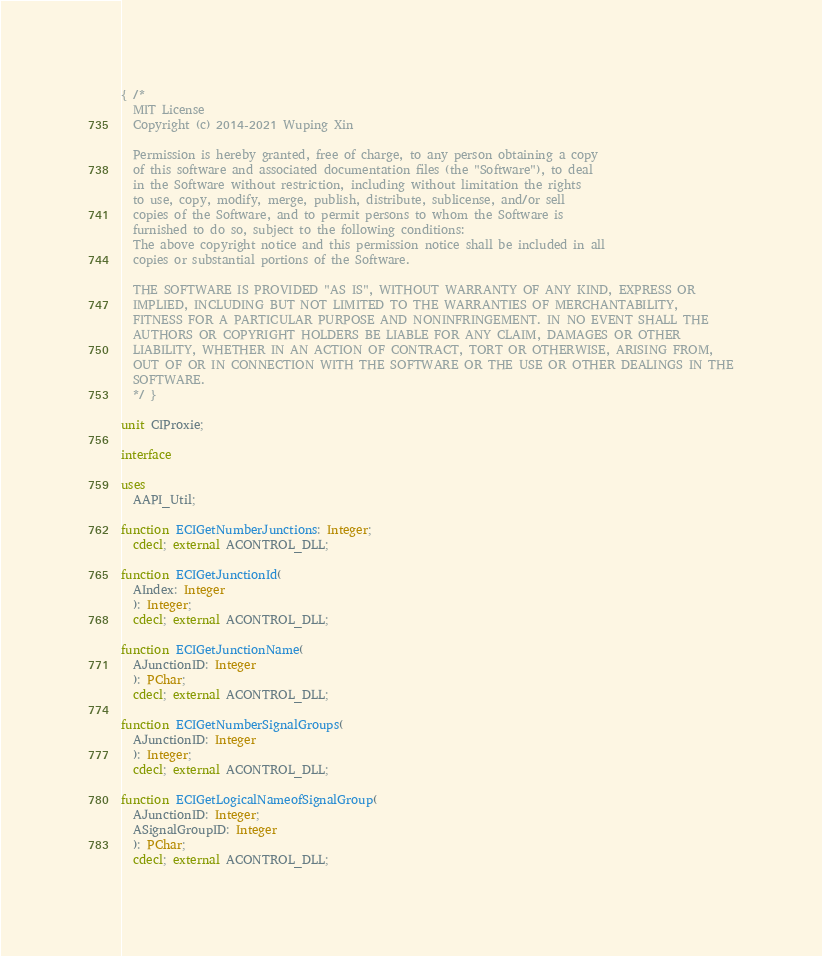Convert code to text. <code><loc_0><loc_0><loc_500><loc_500><_Pascal_>{ /*
  MIT License
  Copyright (c) 2014-2021 Wuping Xin

  Permission is hereby granted, free of charge, to any person obtaining a copy
  of this software and associated documentation files (the "Software"), to deal
  in the Software without restriction, including without limitation the rights
  to use, copy, modify, merge, publish, distribute, sublicense, and/or sell
  copies of the Software, and to permit persons to whom the Software is
  furnished to do so, subject to the following conditions:
  The above copyright notice and this permission notice shall be included in all
  copies or substantial portions of the Software.

  THE SOFTWARE IS PROVIDED "AS IS", WITHOUT WARRANTY OF ANY KIND, EXPRESS OR
  IMPLIED, INCLUDING BUT NOT LIMITED TO THE WARRANTIES OF MERCHANTABILITY,
  FITNESS FOR A PARTICULAR PURPOSE AND NONINFRINGEMENT. IN NO EVENT SHALL THE
  AUTHORS OR COPYRIGHT HOLDERS BE LIABLE FOR ANY CLAIM, DAMAGES OR OTHER
  LIABILITY, WHETHER IN AN ACTION OF CONTRACT, TORT OR OTHERWISE, ARISING FROM,
  OUT OF OR IN CONNECTION WITH THE SOFTWARE OR THE USE OR OTHER DEALINGS IN THE
  SOFTWARE.
  */ }

unit CIProxie;

interface

uses
  AAPI_Util;

function ECIGetNumberJunctions: Integer;
  cdecl; external ACONTROL_DLL;

function ECIGetJunctionId(
  AIndex: Integer
  ): Integer;
  cdecl; external ACONTROL_DLL;

function ECIGetJunctionName(
  AJunctionID: Integer
  ): PChar;
  cdecl; external ACONTROL_DLL;

function ECIGetNumberSignalGroups(
  AJunctionID: Integer
  ): Integer;
  cdecl; external ACONTROL_DLL;

function ECIGetLogicalNameofSignalGroup(
  AJunctionID: Integer;
  ASignalGroupID: Integer
  ): PChar;
  cdecl; external ACONTROL_DLL;
</code> 